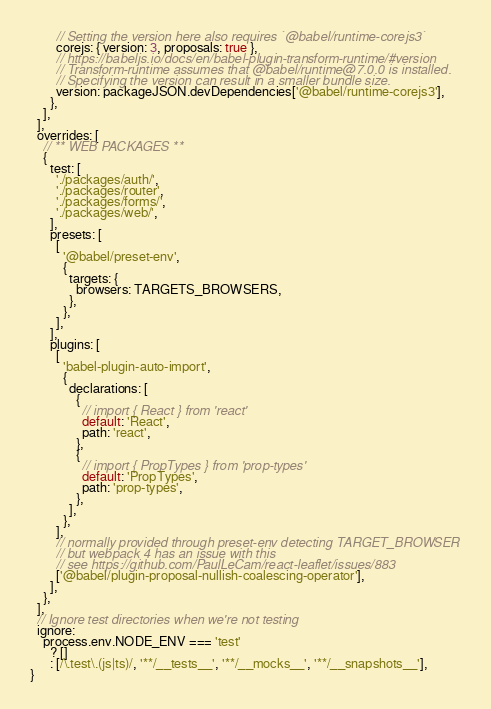<code> <loc_0><loc_0><loc_500><loc_500><_JavaScript_>        // Setting the version here also requires `@babel/runtime-corejs3`
        corejs: { version: 3, proposals: true },
        // https://babeljs.io/docs/en/babel-plugin-transform-runtime/#version
        // Transform-runtime assumes that @babel/runtime@7.0.0 is installed.
        // Specifying the version can result in a smaller bundle size.
        version: packageJSON.devDependencies['@babel/runtime-corejs3'],
      },
    ],
  ],
  overrides: [
    // ** WEB PACKAGES **
    {
      test: [
        './packages/auth/',
        './packages/router',
        './packages/forms/',
        './packages/web/',
      ],
      presets: [
        [
          '@babel/preset-env',
          {
            targets: {
              browsers: TARGETS_BROWSERS,
            },
          },
        ],
      ],
      plugins: [
        [
          'babel-plugin-auto-import',
          {
            declarations: [
              {
                // import { React } from 'react'
                default: 'React',
                path: 'react',
              },
              {
                // import { PropTypes } from 'prop-types'
                default: 'PropTypes',
                path: 'prop-types',
              },
            ],
          },
        ],
        // normally provided through preset-env detecting TARGET_BROWSER
        // but webpack 4 has an issue with this
        // see https://github.com/PaulLeCam/react-leaflet/issues/883
        ['@babel/plugin-proposal-nullish-coalescing-operator'],
      ],
    },
  ],
  // Ignore test directories when we're not testing
  ignore:
    process.env.NODE_ENV === 'test'
      ? []
      : [/\.test\.(js|ts)/, '**/__tests__', '**/__mocks__', '**/__snapshots__'],
}
</code> 